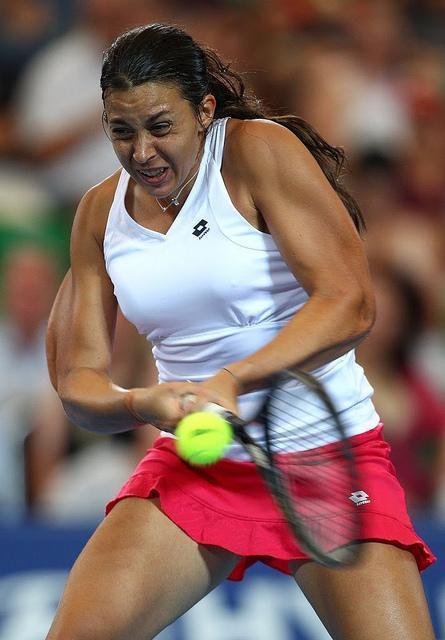How many people are visible?
Give a very brief answer. 4. How many cows are walking in the road?
Give a very brief answer. 0. 